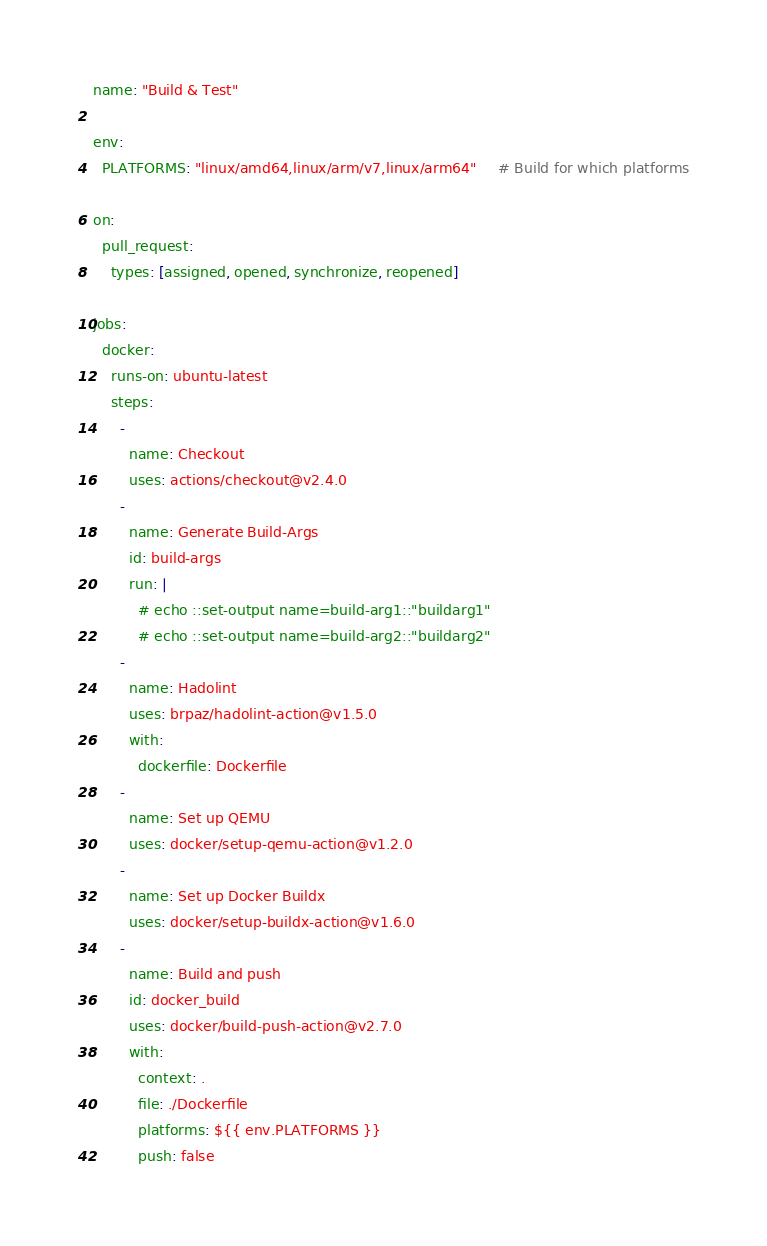Convert code to text. <code><loc_0><loc_0><loc_500><loc_500><_YAML_>name: "Build & Test"

env:
  PLATFORMS: "linux/amd64,linux/arm/v7,linux/arm64"     # Build for which platforms

on:
  pull_request:
    types: [assigned, opened, synchronize, reopened]

jobs:
  docker:
    runs-on: ubuntu-latest
    steps:
      -
        name: Checkout
        uses: actions/checkout@v2.4.0
      -
        name: Generate Build-Args
        id: build-args
        run: |
          # echo ::set-output name=build-arg1::"buildarg1"
          # echo ::set-output name=build-arg2::"buildarg2"
      -
        name: Hadolint
        uses: brpaz/hadolint-action@v1.5.0
        with: 
          dockerfile: Dockerfile
      -
        name: Set up QEMU
        uses: docker/setup-qemu-action@v1.2.0
      -
        name: Set up Docker Buildx
        uses: docker/setup-buildx-action@v1.6.0
      -
        name: Build and push
        id: docker_build
        uses: docker/build-push-action@v2.7.0
        with:
          context: .
          file: ./Dockerfile
          platforms: ${{ env.PLATFORMS }}
          push: false</code> 